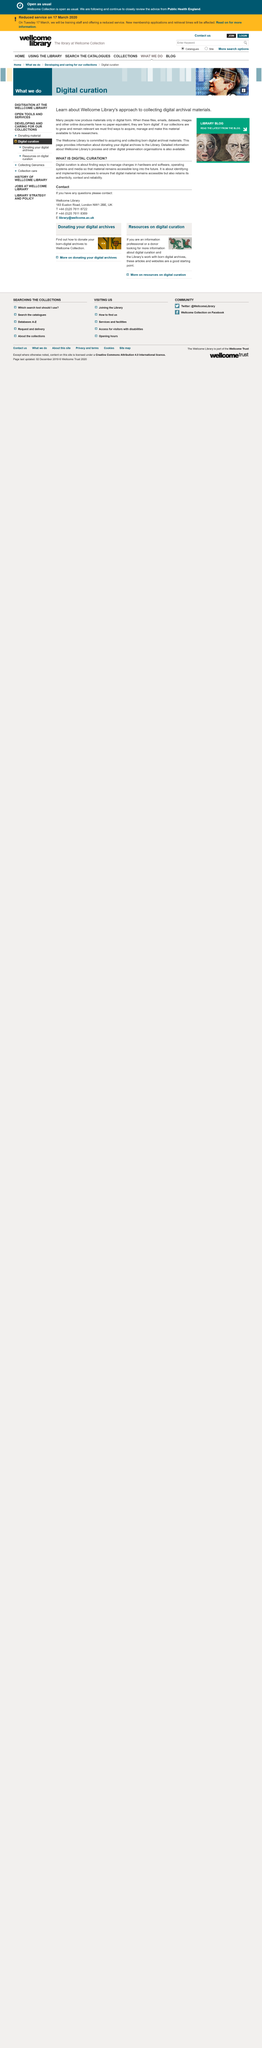Mention a couple of crucial points in this snapshot. Digital curation is the process of finding and implementing strategies to preserve and maintain access to digital material in the face of changing hardware and software, operating systems, and media, so that it remains available for future use. It is essential to ensure that digital material remains accessible while preserving its authenticity, context, and reliability. Digital curation is the process of finding ways to manage changes in hardware and software, operating systems, and media so that material remains accessible long into the future. 